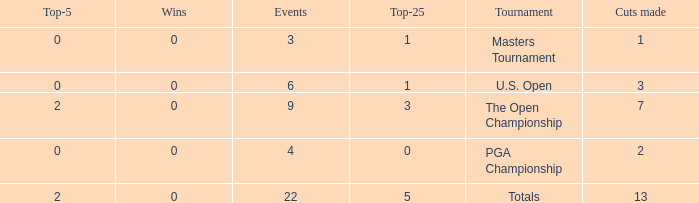How many total cuts were made in events with more than 0 wins and exactly 0 top-5s? 0.0. 